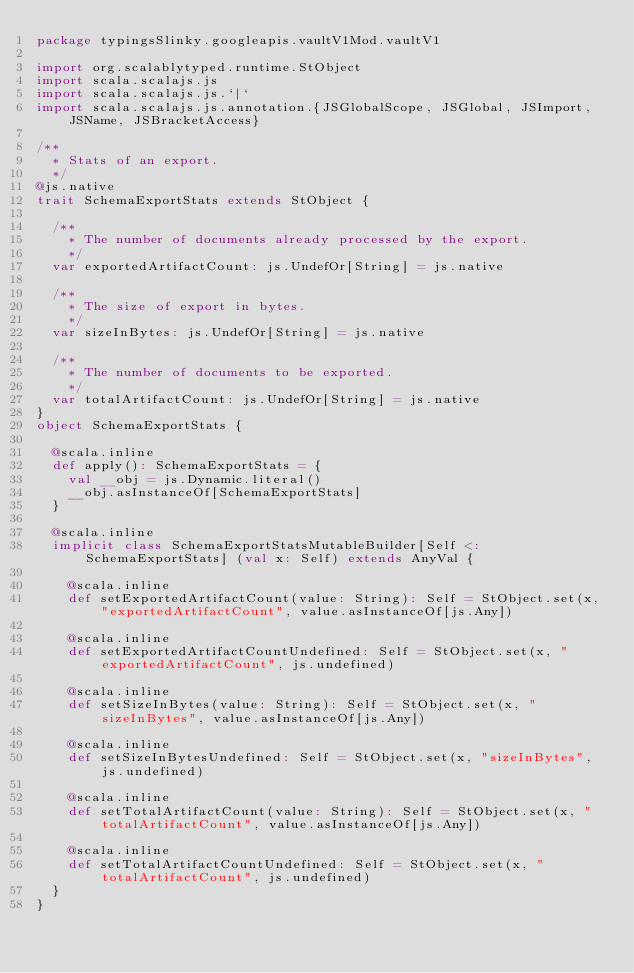Convert code to text. <code><loc_0><loc_0><loc_500><loc_500><_Scala_>package typingsSlinky.googleapis.vaultV1Mod.vaultV1

import org.scalablytyped.runtime.StObject
import scala.scalajs.js
import scala.scalajs.js.`|`
import scala.scalajs.js.annotation.{JSGlobalScope, JSGlobal, JSImport, JSName, JSBracketAccess}

/**
  * Stats of an export.
  */
@js.native
trait SchemaExportStats extends StObject {
  
  /**
    * The number of documents already processed by the export.
    */
  var exportedArtifactCount: js.UndefOr[String] = js.native
  
  /**
    * The size of export in bytes.
    */
  var sizeInBytes: js.UndefOr[String] = js.native
  
  /**
    * The number of documents to be exported.
    */
  var totalArtifactCount: js.UndefOr[String] = js.native
}
object SchemaExportStats {
  
  @scala.inline
  def apply(): SchemaExportStats = {
    val __obj = js.Dynamic.literal()
    __obj.asInstanceOf[SchemaExportStats]
  }
  
  @scala.inline
  implicit class SchemaExportStatsMutableBuilder[Self <: SchemaExportStats] (val x: Self) extends AnyVal {
    
    @scala.inline
    def setExportedArtifactCount(value: String): Self = StObject.set(x, "exportedArtifactCount", value.asInstanceOf[js.Any])
    
    @scala.inline
    def setExportedArtifactCountUndefined: Self = StObject.set(x, "exportedArtifactCount", js.undefined)
    
    @scala.inline
    def setSizeInBytes(value: String): Self = StObject.set(x, "sizeInBytes", value.asInstanceOf[js.Any])
    
    @scala.inline
    def setSizeInBytesUndefined: Self = StObject.set(x, "sizeInBytes", js.undefined)
    
    @scala.inline
    def setTotalArtifactCount(value: String): Self = StObject.set(x, "totalArtifactCount", value.asInstanceOf[js.Any])
    
    @scala.inline
    def setTotalArtifactCountUndefined: Self = StObject.set(x, "totalArtifactCount", js.undefined)
  }
}
</code> 